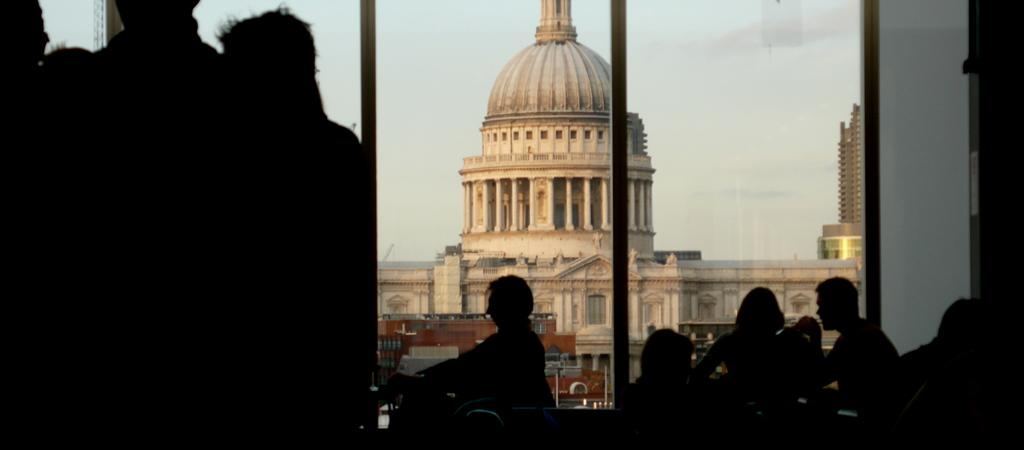How many people are in the image? There are persons in the image, but the exact number is not specified. What can be seen in the background of the image? There are buildings and the sky visible in the background of the image. What type of design is being exchanged between the persons in the image? There is no information about any design or exchange between the persons in the image. 